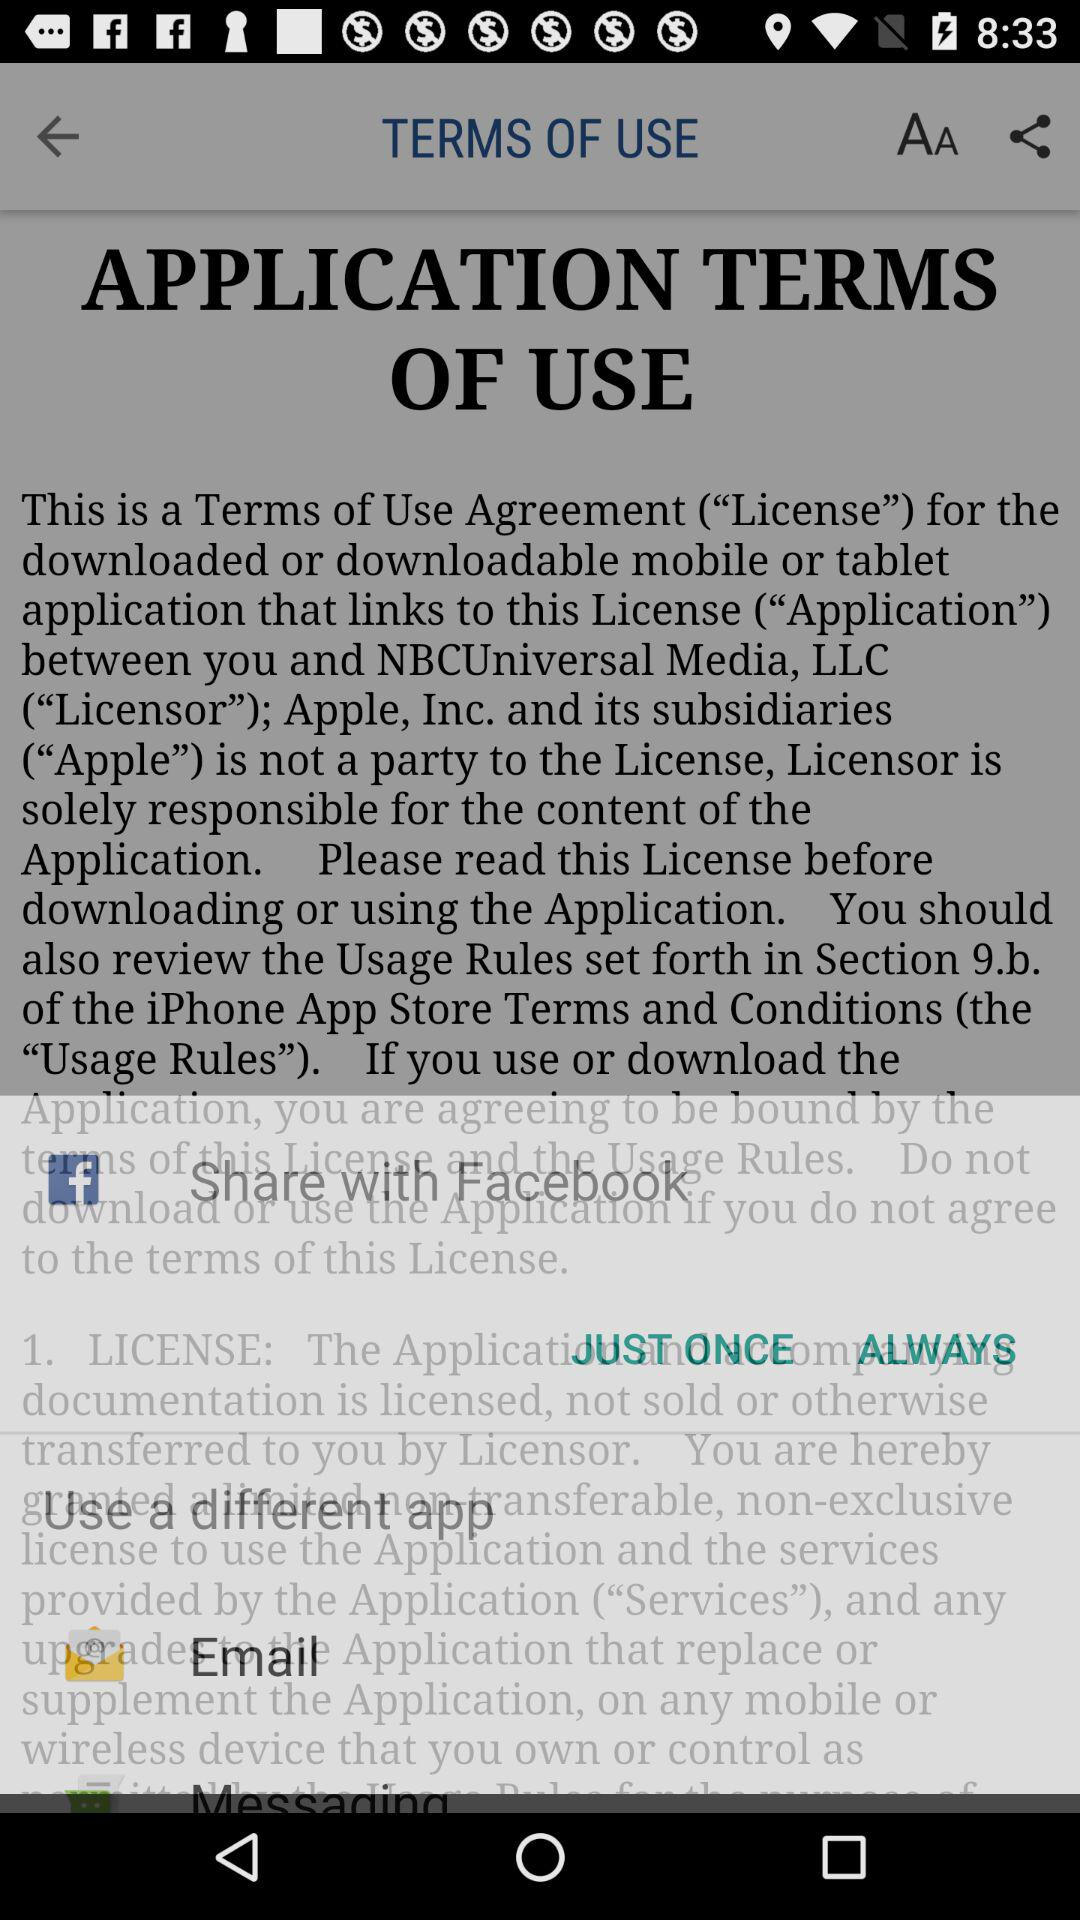Is "JUST ONCE" selected?
When the provided information is insufficient, respond with <no answer>. <no answer> 